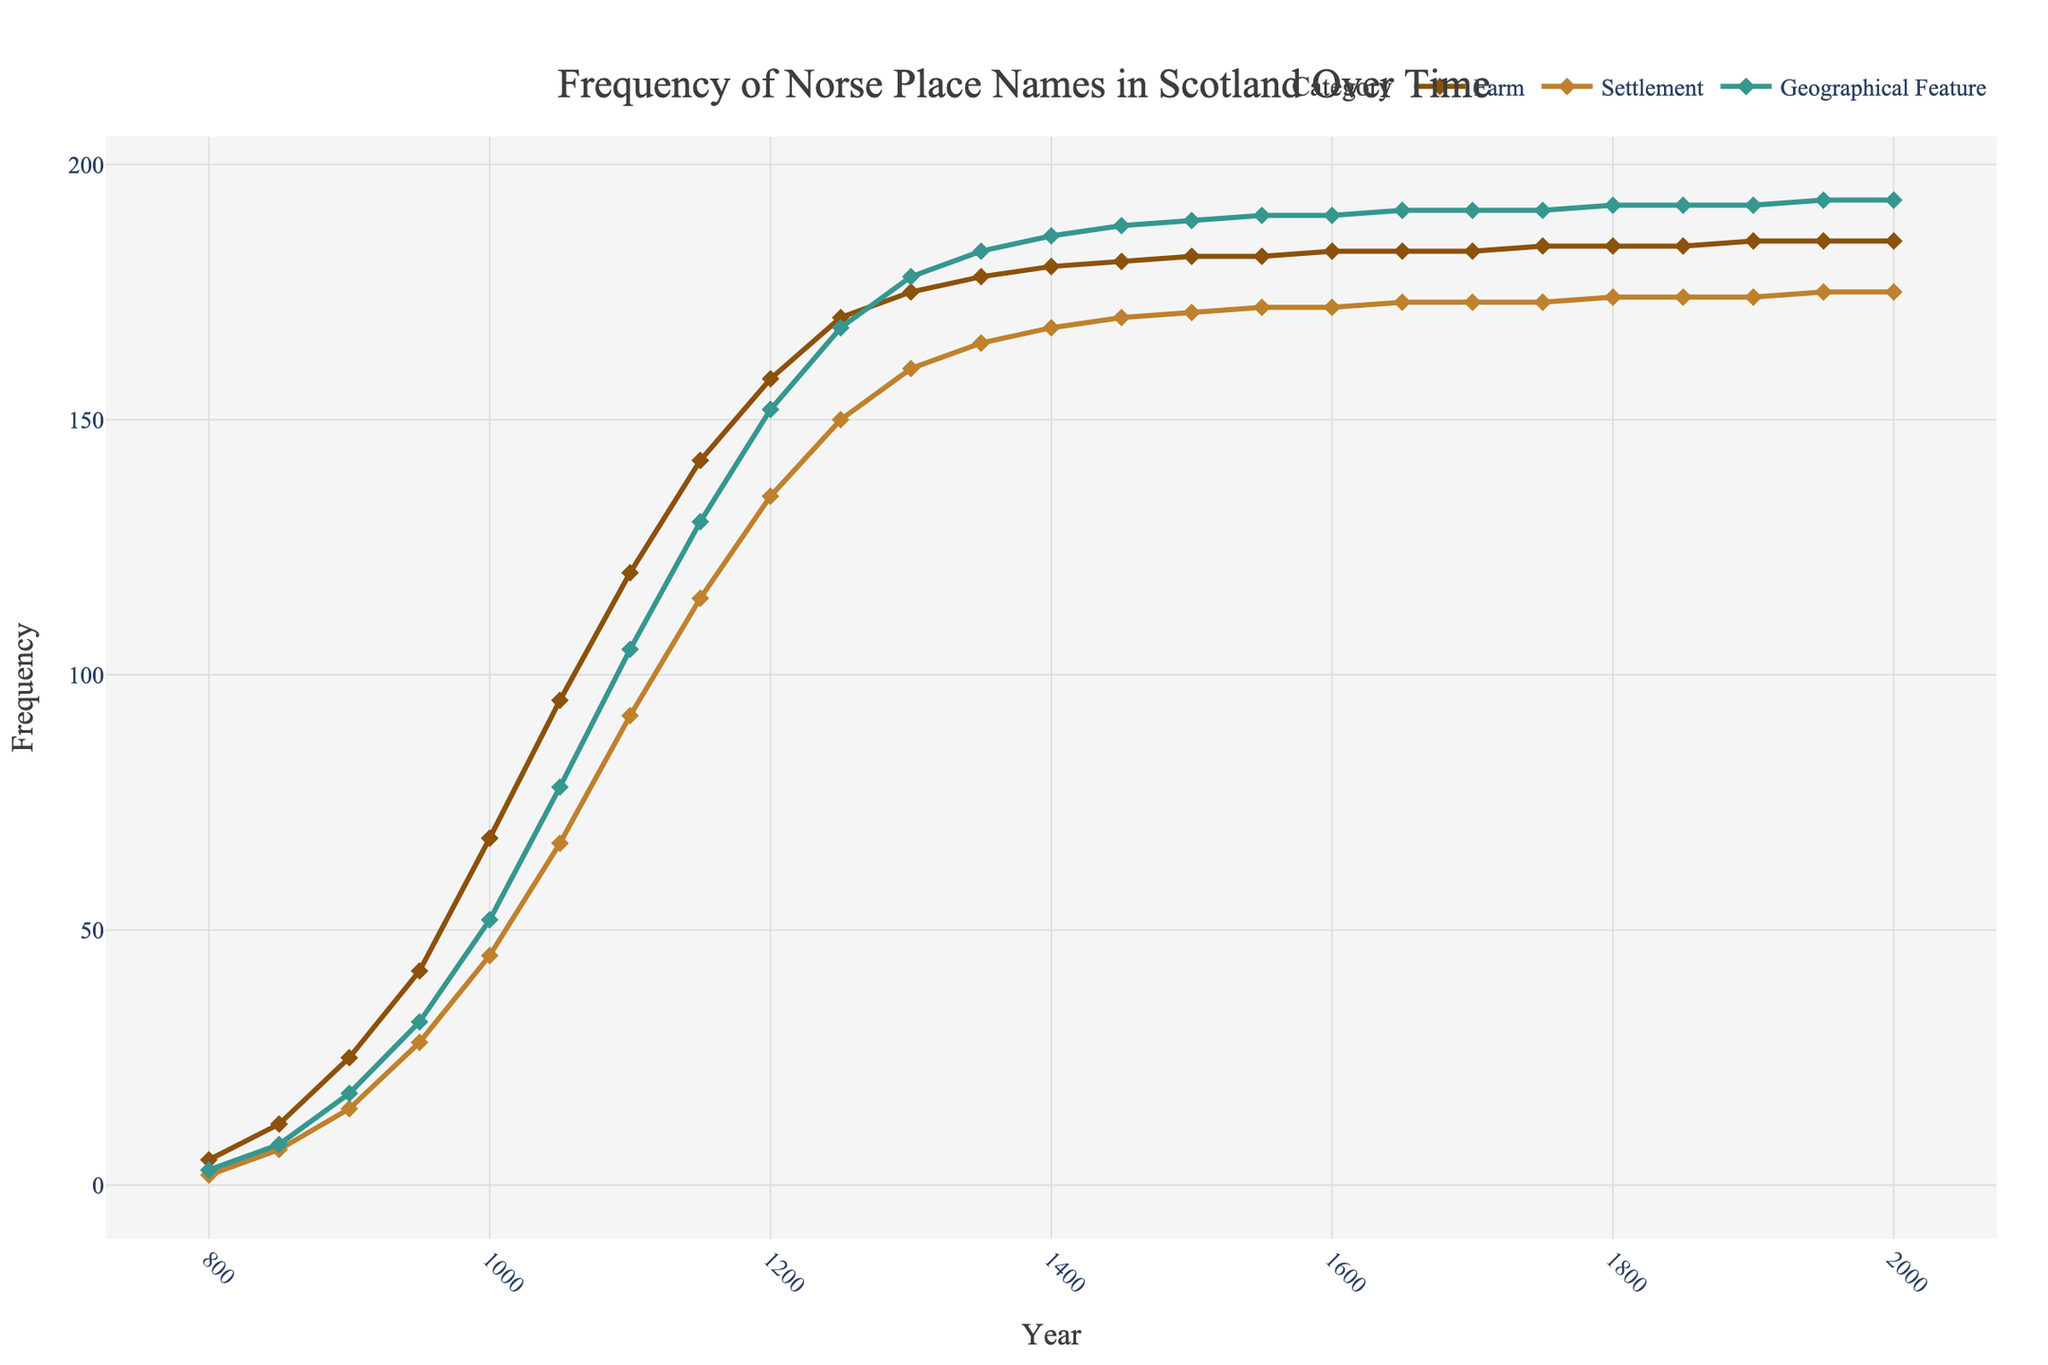What year saw the peak frequency of Norse place names categorized as farms? The line representing 'Farm' in the chart reaches its highest value during the period around the year 1150, as is apparent from the visual marker on the graph.
Answer: 1200 Which type of place name had the highest frequency in the year 1000? By observing the lines on the graph in the year 1000, the 'Farm' category reaches the highest point compared to 'Settlement' and 'Geographical Feature'.
Answer: Farm By how much did the frequency of Norse settlements increase between 850 and 950? The frequency of settlements was 7 in the year 850 and increased to 28 by 950. Therefore, the increase is 28 - 7 = 21.
Answer: 21 Did geographical features or settlements have a higher frequency overall in the year 1400? At the year 1400, the line for 'Geographical Feature' is higher on the graph than the line for 'Settlement', indicating more geographical features.
Answer: Geographical Features How does the frequency of farms compare to settlements in the year 1750? In the year 1750, the line for 'Farm' is higher than the line for 'Settlement', indicating that farms were more frequent than settlements during that year.
Answer: Farms What is the trend observed from the frequencies of all place name categories between the years 1300 and 1600? Observing the lines, it can be noted that all categories show a gradual increase in frequency during this period. The steady incline for each category becomes apparent, with noticeable peaks around mid-points.
Answer: Gradual increase Calculate the average frequency of Norse place names as geographical features between 800 and 1000. Summing the values for the geographical features between 800 and 1000 (3 + 8 + 18 + 32 + 52) gives 113. Dividing this by 5 (the number of data points) results in an average of 22.6.
Answer: 22.6 Around the year 1950, what can you infer about the trend of the place names? Around the year 1950, the line for each category (Farm, Settlement, Geographical Feature) becomes relatively flat, signaling that the frequency has stabilized and is not significantly increasing or decreasing.
Answer: Stabilized In which period is the greatest change observed in all types of place names? The period between 950 and 1150 shows the steepest slopes across all three lines (Farm, Settlement, Geographical Feature), indicating that this is when the most significant changes occurred.
Answer: 950-1150 How many more geographical features were there than farms around the year 800? In the year 800, the frequency of farms is 5, and geographical features are 3. Subtracting the frequencies gives 5 - 3 = 2, indicating more farms.
Answer: 2 